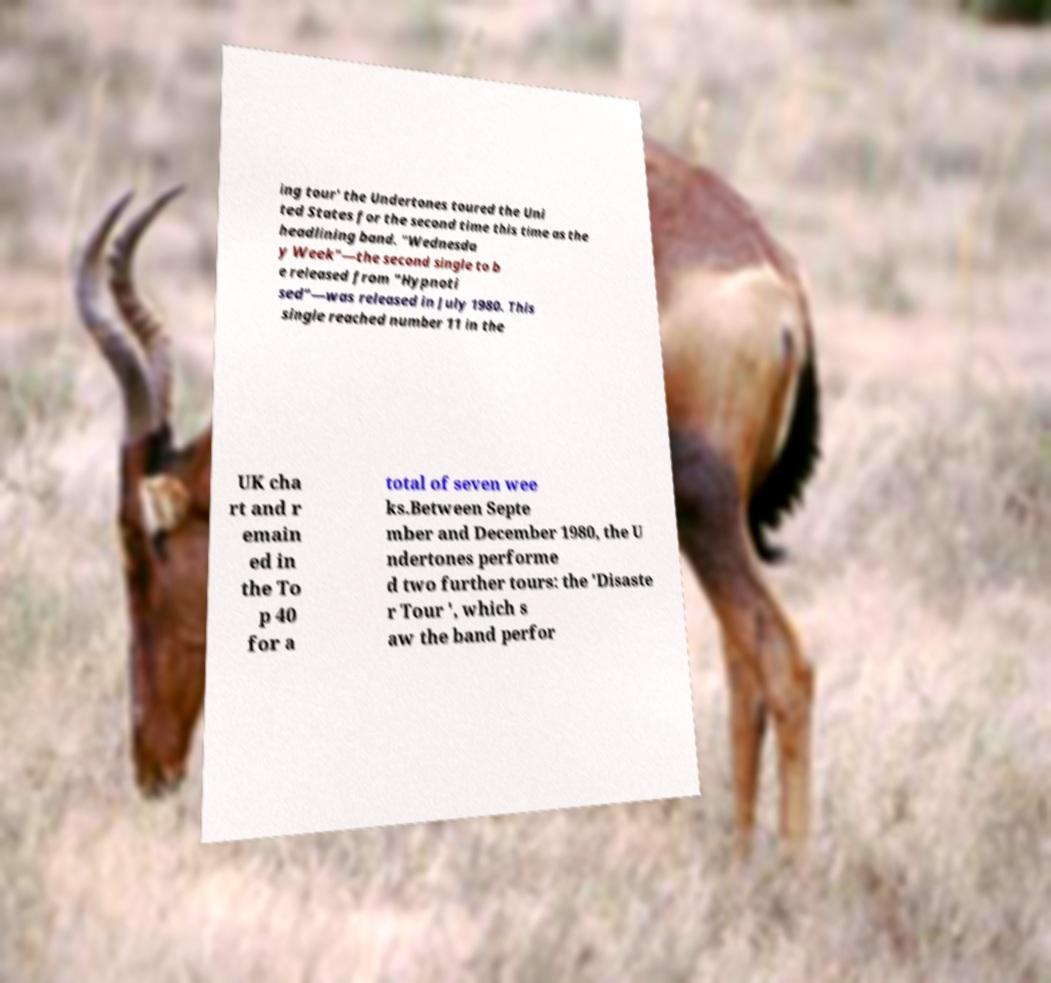Can you accurately transcribe the text from the provided image for me? ing tour' the Undertones toured the Uni ted States for the second time this time as the headlining band. "Wednesda y Week"—the second single to b e released from "Hypnoti sed"—was released in July 1980. This single reached number 11 in the UK cha rt and r emain ed in the To p 40 for a total of seven wee ks.Between Septe mber and December 1980, the U ndertones performe d two further tours: the 'Disaste r Tour ', which s aw the band perfor 